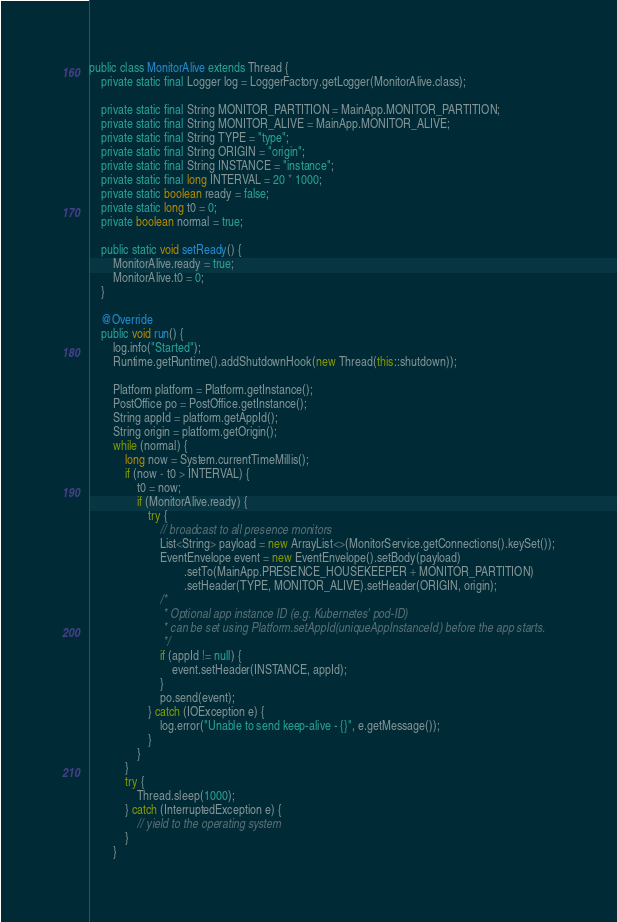<code> <loc_0><loc_0><loc_500><loc_500><_Java_>public class MonitorAlive extends Thread {
    private static final Logger log = LoggerFactory.getLogger(MonitorAlive.class);

    private static final String MONITOR_PARTITION = MainApp.MONITOR_PARTITION;
    private static final String MONITOR_ALIVE = MainApp.MONITOR_ALIVE;
    private static final String TYPE = "type";
    private static final String ORIGIN = "origin";
    private static final String INSTANCE = "instance";
    private static final long INTERVAL = 20 * 1000;
    private static boolean ready = false;
    private static long t0 = 0;
    private boolean normal = true;

    public static void setReady() {
        MonitorAlive.ready = true;
        MonitorAlive.t0 = 0;
    }

    @Override
    public void run() {
        log.info("Started");
        Runtime.getRuntime().addShutdownHook(new Thread(this::shutdown));

        Platform platform = Platform.getInstance();
        PostOffice po = PostOffice.getInstance();
        String appId = platform.getAppId();
        String origin = platform.getOrigin();
        while (normal) {
            long now = System.currentTimeMillis();
            if (now - t0 > INTERVAL) {
                t0 = now;
                if (MonitorAlive.ready) {
                    try {
                        // broadcast to all presence monitors
                        List<String> payload = new ArrayList<>(MonitorService.getConnections().keySet());
                        EventEnvelope event = new EventEnvelope().setBody(payload)
                                .setTo(MainApp.PRESENCE_HOUSEKEEPER + MONITOR_PARTITION)
                                .setHeader(TYPE, MONITOR_ALIVE).setHeader(ORIGIN, origin);
                        /*
                         * Optional app instance ID (e.g. Kubernetes' pod-ID)
                         * can be set using Platform.setAppId(uniqueAppInstanceId) before the app starts.
                         */
                        if (appId != null) {
                            event.setHeader(INSTANCE, appId);
                        }
                        po.send(event);
                    } catch (IOException e) {
                        log.error("Unable to send keep-alive - {}", e.getMessage());
                    }
                }
            }
            try {
                Thread.sleep(1000);
            } catch (InterruptedException e) {
                // yield to the operating system
            }
        }</code> 